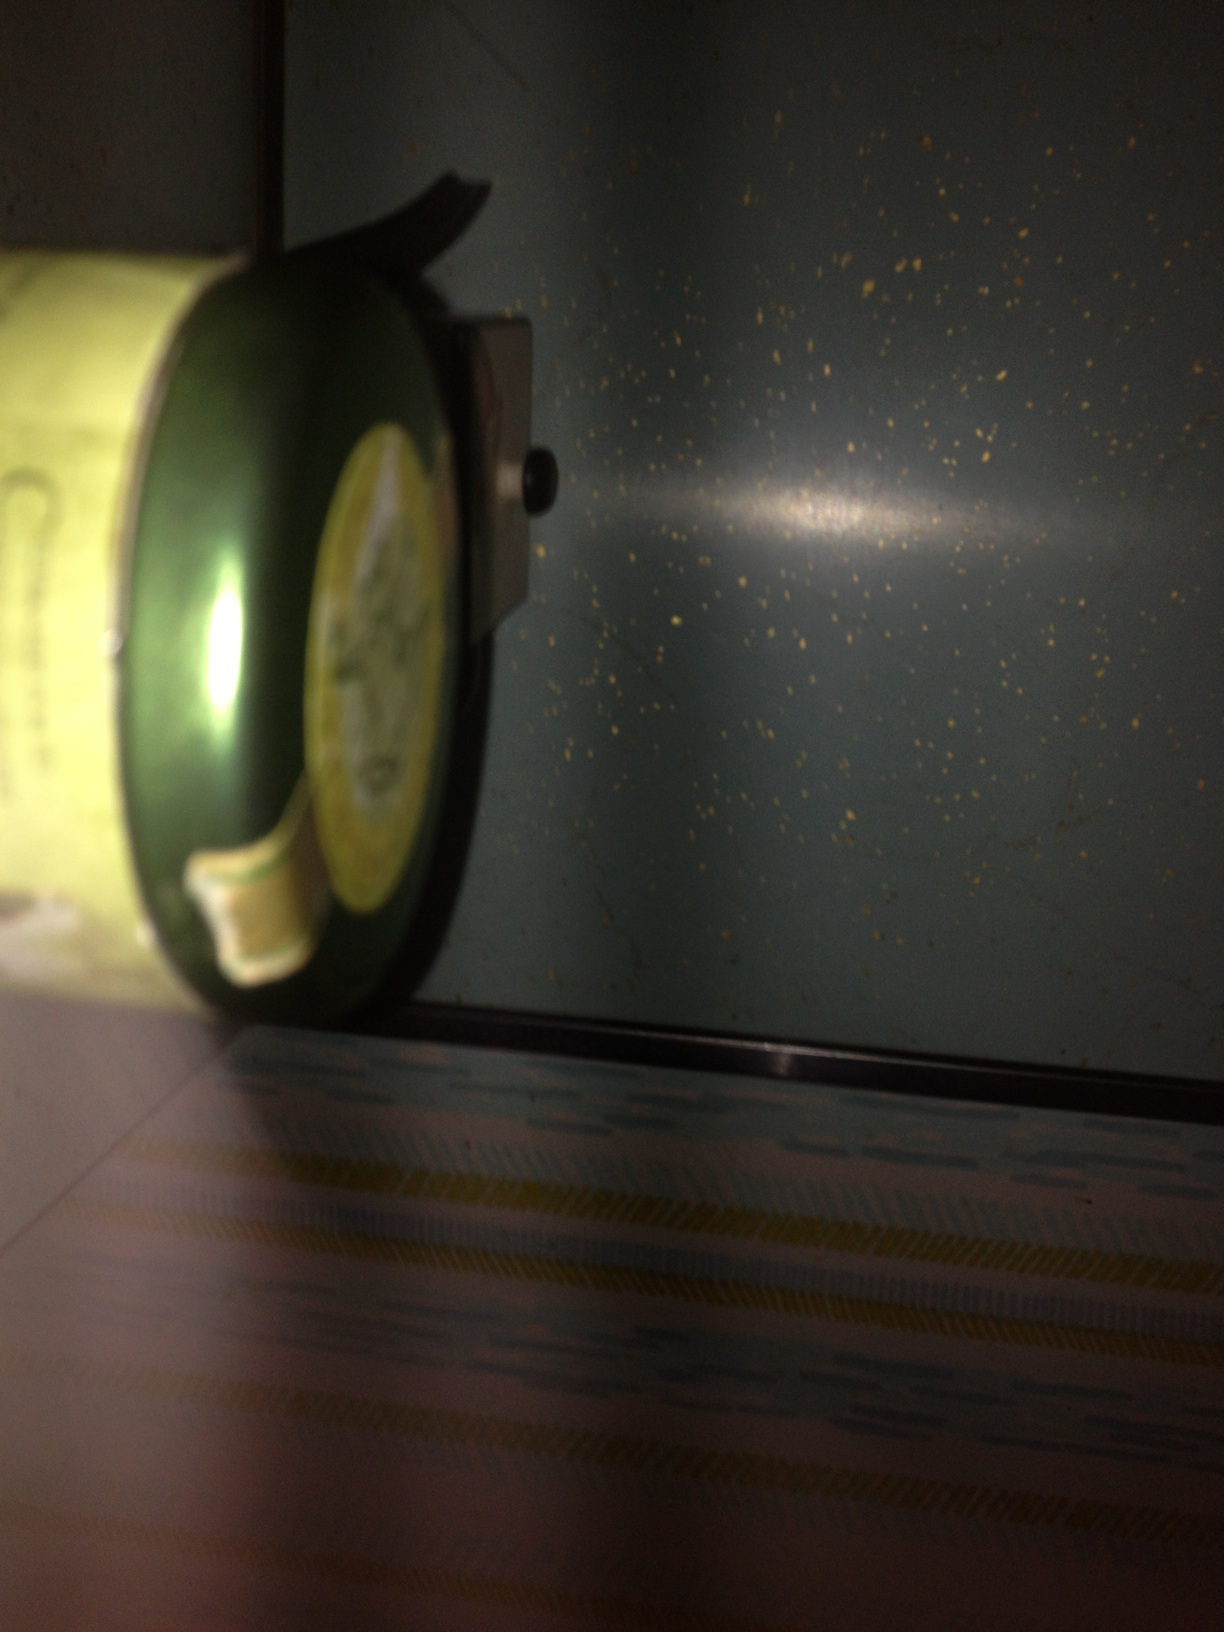What can you imagine about the story behind this can? This can could have a fascinating story behind it! It might be a keepsake from someone's travels to an exotic location known for its unique blend of teas. Perhaps it was a gift, symbolizing warmth and friendship, given during a memorable occasion. The can might also be part of a limited edition series, cherished by a tea enthusiast who collects different kinds of tea from around the world. If this can were part of a tea ceremony, what would that ceremony look like? In an elaborate tea ceremony, this can would be carefully opened as participants gathered respectfully around a traditional tea setup. The host would measure the leaves with precision, adhering to ancient customs. Hot water, boiled to the perfect temperature, would be poured over the tea leaves. As the tea steeps, a serene silence would prevail, allowing the rich aroma to fill the air. The tea would then be poured into delicate cups, each sip taken in reflective appreciation of the flavors, the skill of the preparation, and the cultural significance of the ceremony. Imagine this can is magic; what powers does it have? Imagine this can is imbued with ancient magic! Upon opening, it unveils a mystical aura that grants the drinker wisdom and clarity of thought. The tea inside, when steeped, glows faintly, indicating its enchanted nature. Drinking the tea from this can could possibly unveil hidden truths, nourish the mind with profound insights, and perhaps even allow one to glimpse into the future. Each sip is a journey into the realms of imagination and enlightenment.  A person finds this can in an old attic. What might their experience be? Exploring the dusty attic, a person stumbles upon this can buried under cobwebs and old books. The aged yet intriguing label catches their eye, hinting at a time long past. As they open the can, they are transported back to the era it came from, maybe to bustling markets or serene tea gardens. The scent of the tea brings memories or imaginations of the rich history associated with it. It's a serendipitous moment of connection to the past, filled with curiosity and wonder.  What might have been the original purpose of this can? The original purpose of this can was likely to store tea leaves securely, keeping them fresh and aromatic. Its design and material were probably chosen to protect the tea from moisture, light, and air, ensuring that each brew retains the rich flavors and health benefits of the tea. Additionally, the can's aesthetic might have been designed to attract consumers, reflecting the quality and tradition of the tea company. 